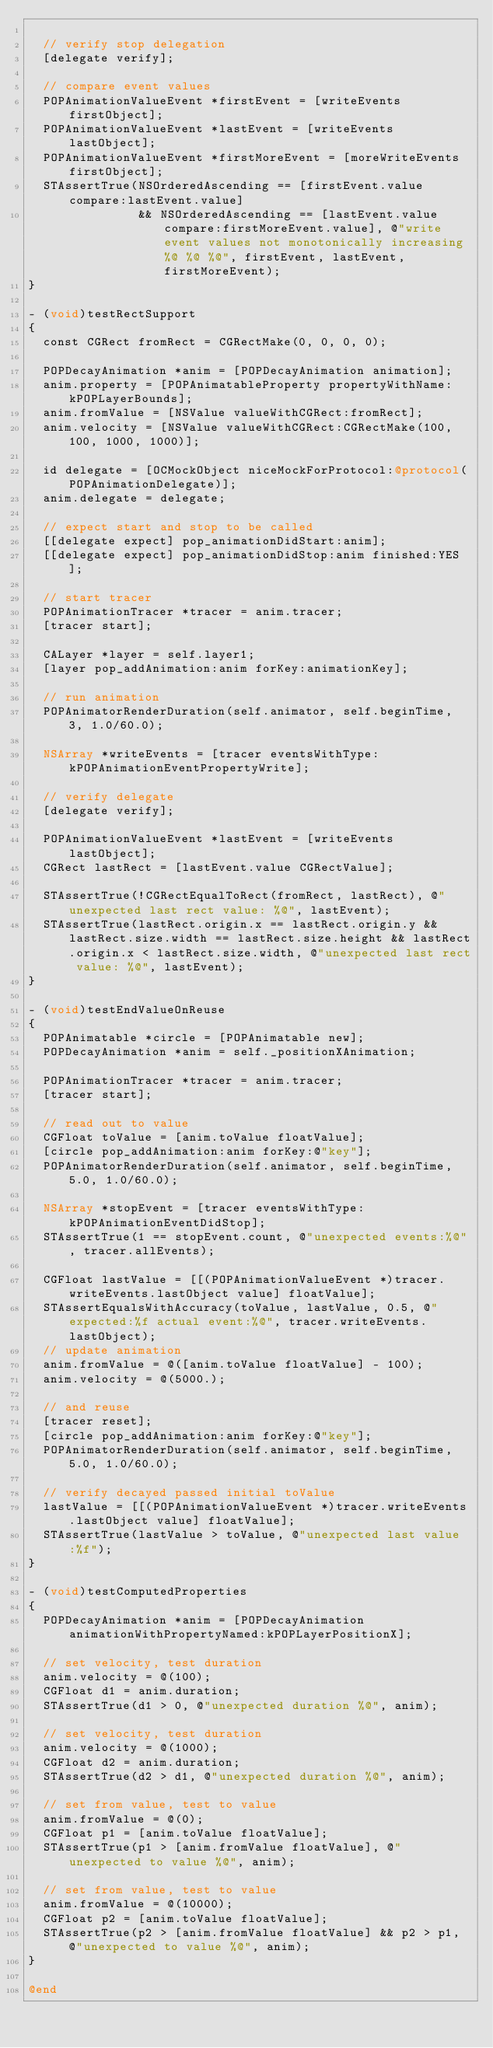Convert code to text. <code><loc_0><loc_0><loc_500><loc_500><_ObjectiveC_>
  // verify stop delegation
  [delegate verify];

  // compare event values
  POPAnimationValueEvent *firstEvent = [writeEvents firstObject];
  POPAnimationValueEvent *lastEvent = [writeEvents lastObject];
  POPAnimationValueEvent *firstMoreEvent = [moreWriteEvents firstObject];
  STAssertTrue(NSOrderedAscending == [firstEvent.value compare:lastEvent.value]
               && NSOrderedAscending == [lastEvent.value compare:firstMoreEvent.value], @"write event values not monotonically increasing %@ %@ %@", firstEvent, lastEvent, firstMoreEvent);
}

- (void)testRectSupport
{
  const CGRect fromRect = CGRectMake(0, 0, 0, 0);

  POPDecayAnimation *anim = [POPDecayAnimation animation];
  anim.property = [POPAnimatableProperty propertyWithName:kPOPLayerBounds];
  anim.fromValue = [NSValue valueWithCGRect:fromRect];
  anim.velocity = [NSValue valueWithCGRect:CGRectMake(100, 100, 1000, 1000)];
  
  id delegate = [OCMockObject niceMockForProtocol:@protocol(POPAnimationDelegate)];
  anim.delegate = delegate;

  // expect start and stop to be called
  [[delegate expect] pop_animationDidStart:anim];
  [[delegate expect] pop_animationDidStop:anim finished:YES];

  // start tracer
  POPAnimationTracer *tracer = anim.tracer;
  [tracer start];

  CALayer *layer = self.layer1;
  [layer pop_addAnimation:anim forKey:animationKey];

  // run animation
  POPAnimatorRenderDuration(self.animator, self.beginTime, 3, 1.0/60.0);
  
  NSArray *writeEvents = [tracer eventsWithType:kPOPAnimationEventPropertyWrite];

  // verify delegate
  [delegate verify];

  POPAnimationValueEvent *lastEvent = [writeEvents lastObject];
  CGRect lastRect = [lastEvent.value CGRectValue];
  
  STAssertTrue(!CGRectEqualToRect(fromRect, lastRect), @"unexpected last rect value: %@", lastEvent);
  STAssertTrue(lastRect.origin.x == lastRect.origin.y && lastRect.size.width == lastRect.size.height && lastRect.origin.x < lastRect.size.width, @"unexpected last rect value: %@", lastEvent);
}

- (void)testEndValueOnReuse
{
  POPAnimatable *circle = [POPAnimatable new];
  POPDecayAnimation *anim = self._positionXAnimation;
  
  POPAnimationTracer *tracer = anim.tracer;
  [tracer start];
  
  // read out to value
  CGFloat toValue = [anim.toValue floatValue];
  [circle pop_addAnimation:anim forKey:@"key"];
  POPAnimatorRenderDuration(self.animator, self.beginTime, 5.0, 1.0/60.0);

  NSArray *stopEvent = [tracer eventsWithType:kPOPAnimationEventDidStop];
  STAssertTrue(1 == stopEvent.count, @"unexpected events:%@", tracer.allEvents);

  CGFloat lastValue = [[(POPAnimationValueEvent *)tracer.writeEvents.lastObject value] floatValue];
  STAssertEqualsWithAccuracy(toValue, lastValue, 0.5, @"expected:%f actual event:%@", tracer.writeEvents.lastObject);
  // update animation
  anim.fromValue = @([anim.toValue floatValue] - 100);
  anim.velocity = @(5000.);

  // and reuse
  [tracer reset];
  [circle pop_addAnimation:anim forKey:@"key"];
  POPAnimatorRenderDuration(self.animator, self.beginTime, 5.0, 1.0/60.0);

  // verify decayed passed initial toValue
  lastValue = [[(POPAnimationValueEvent *)tracer.writeEvents.lastObject value] floatValue];
  STAssertTrue(lastValue > toValue, @"unexpected last value:%f");
}

- (void)testComputedProperties
{
  POPDecayAnimation *anim = [POPDecayAnimation animationWithPropertyNamed:kPOPLayerPositionX];
  
  // set velocity, test duration
  anim.velocity = @(100);
  CGFloat d1 = anim.duration;
  STAssertTrue(d1 > 0, @"unexpected duration %@", anim);
  
  // set velocity, test duration
  anim.velocity = @(1000);
  CGFloat d2 = anim.duration;
  STAssertTrue(d2 > d1, @"unexpected duration %@", anim);

  // set from value, test to value
  anim.fromValue = @(0);
  CGFloat p1 = [anim.toValue floatValue];
  STAssertTrue(p1 > [anim.fromValue floatValue], @"unexpected to value %@", anim);
  
  // set from value, test to value
  anim.fromValue = @(10000);
  CGFloat p2 = [anim.toValue floatValue];
  STAssertTrue(p2 > [anim.fromValue floatValue] && p2 > p1, @"unexpected to value %@", anim);
}

@end
</code> 